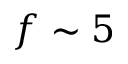Convert formula to latex. <formula><loc_0><loc_0><loc_500><loc_500>f \sim 5</formula> 